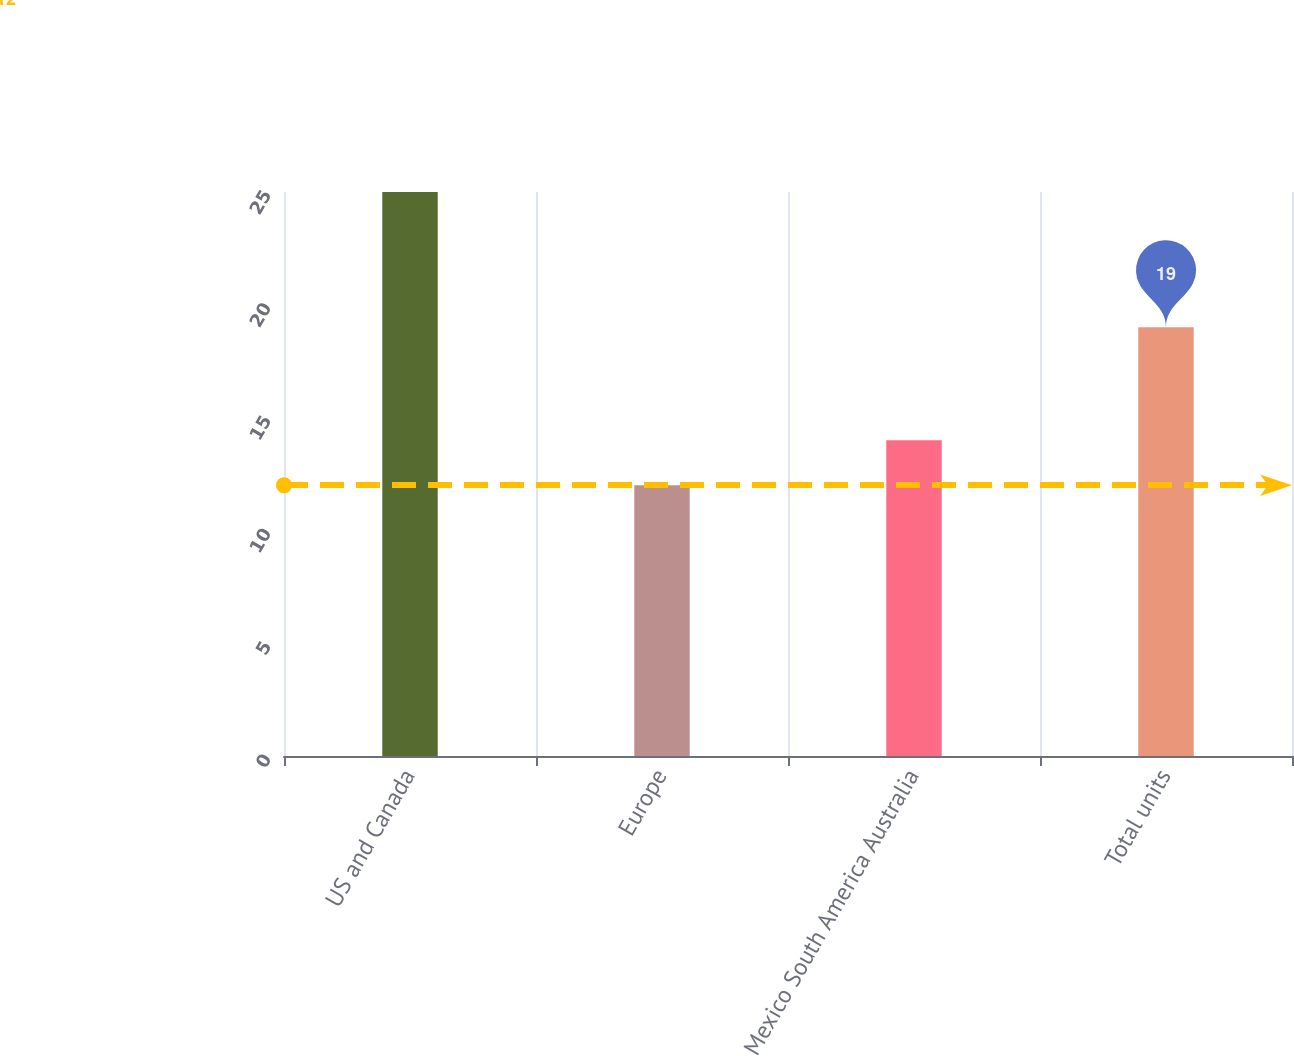Convert chart. <chart><loc_0><loc_0><loc_500><loc_500><bar_chart><fcel>US and Canada<fcel>Europe<fcel>Mexico South America Australia<fcel>Total units<nl><fcel>25<fcel>12<fcel>14<fcel>19<nl></chart> 